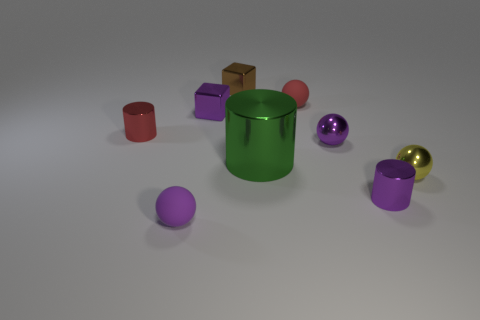Do the small yellow thing and the small purple sphere in front of the yellow metal thing have the same material?
Offer a terse response. No. What number of things are either small metal objects in front of the large shiny cylinder or green metallic cylinders?
Provide a succinct answer. 3. Is there a tiny matte object that has the same color as the large object?
Give a very brief answer. No. There is a tiny brown thing; is its shape the same as the red object that is left of the purple matte object?
Give a very brief answer. No. How many small balls are behind the green metallic cylinder and in front of the small purple cylinder?
Give a very brief answer. 0. There is a red thing that is the same shape as the large green thing; what is it made of?
Ensure brevity in your answer.  Metal. There is a rubber object that is behind the tiny matte sphere in front of the red cylinder; how big is it?
Your answer should be compact. Small. Is there a big cyan sphere?
Give a very brief answer. No. The object that is in front of the tiny yellow shiny ball and on the left side of the green cylinder is made of what material?
Give a very brief answer. Rubber. Is the number of small purple objects that are behind the red ball greater than the number of small purple things behind the small brown metal block?
Your answer should be compact. No. 